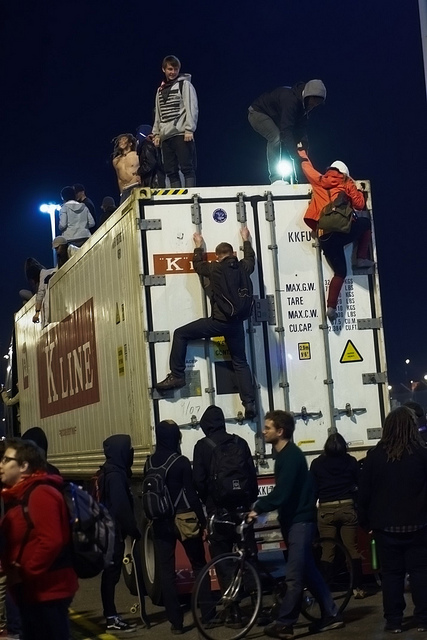What are the people doing on the container? The people appear to be climbing on and exploring the large metal shipping container, with some reaching the top and others in various stages of ascent or descent. It seems like an adventurous and potentially social activity. 